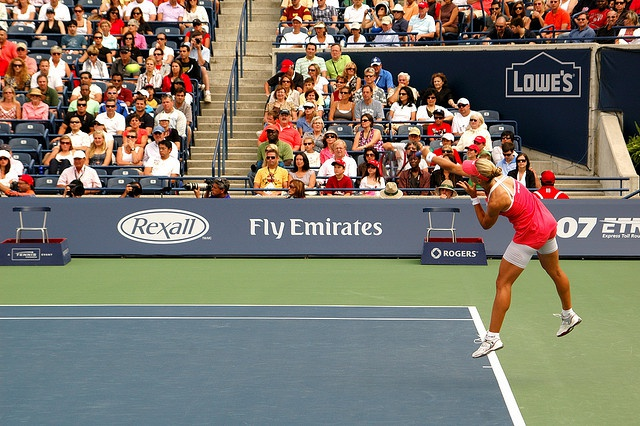Describe the objects in this image and their specific colors. I can see people in salmon, black, white, tan, and maroon tones, people in salmon, brown, maroon, red, and white tones, chair in salmon, gray, black, darkgray, and white tones, people in salmon, gold, orange, brown, and khaki tones, and people in salmon, maroon, black, and brown tones in this image. 